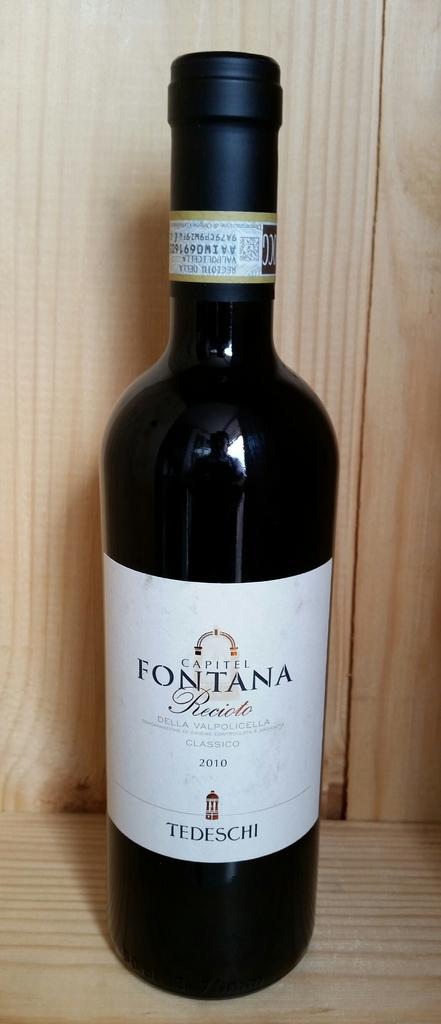What date is shown on this bottle?
Offer a terse response. 2010. 